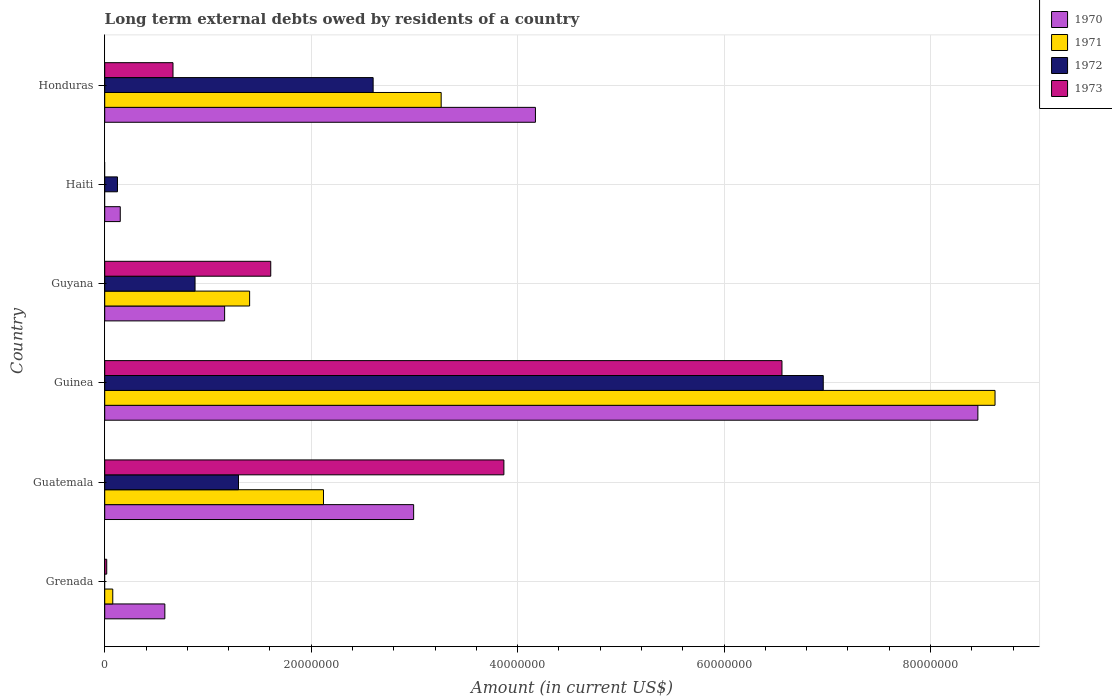How many groups of bars are there?
Offer a terse response. 6. Are the number of bars on each tick of the Y-axis equal?
Keep it short and to the point. No. How many bars are there on the 5th tick from the bottom?
Offer a very short reply. 2. What is the label of the 3rd group of bars from the top?
Ensure brevity in your answer.  Guyana. What is the amount of long-term external debts owed by residents in 1972 in Guyana?
Your response must be concise. 8.75e+06. Across all countries, what is the maximum amount of long-term external debts owed by residents in 1971?
Keep it short and to the point. 8.63e+07. Across all countries, what is the minimum amount of long-term external debts owed by residents in 1970?
Keep it short and to the point. 1.51e+06. In which country was the amount of long-term external debts owed by residents in 1973 maximum?
Your response must be concise. Guinea. What is the total amount of long-term external debts owed by residents in 1970 in the graph?
Your response must be concise. 1.75e+08. What is the difference between the amount of long-term external debts owed by residents in 1973 in Guinea and that in Guyana?
Make the answer very short. 4.95e+07. What is the difference between the amount of long-term external debts owed by residents in 1973 in Guinea and the amount of long-term external debts owed by residents in 1972 in Guatemala?
Your response must be concise. 5.27e+07. What is the average amount of long-term external debts owed by residents in 1972 per country?
Provide a succinct answer. 1.98e+07. What is the difference between the amount of long-term external debts owed by residents in 1971 and amount of long-term external debts owed by residents in 1973 in Guyana?
Keep it short and to the point. -2.05e+06. What is the ratio of the amount of long-term external debts owed by residents in 1971 in Grenada to that in Guyana?
Your response must be concise. 0.06. Is the difference between the amount of long-term external debts owed by residents in 1971 in Guatemala and Guinea greater than the difference between the amount of long-term external debts owed by residents in 1973 in Guatemala and Guinea?
Ensure brevity in your answer.  No. What is the difference between the highest and the second highest amount of long-term external debts owed by residents in 1973?
Your answer should be very brief. 2.69e+07. What is the difference between the highest and the lowest amount of long-term external debts owed by residents in 1971?
Your response must be concise. 8.63e+07. In how many countries, is the amount of long-term external debts owed by residents in 1970 greater than the average amount of long-term external debts owed by residents in 1970 taken over all countries?
Your answer should be compact. 3. Is the sum of the amount of long-term external debts owed by residents in 1972 in Guatemala and Guyana greater than the maximum amount of long-term external debts owed by residents in 1971 across all countries?
Offer a terse response. No. Is it the case that in every country, the sum of the amount of long-term external debts owed by residents in 1972 and amount of long-term external debts owed by residents in 1971 is greater than the amount of long-term external debts owed by residents in 1973?
Give a very brief answer. No. Are all the bars in the graph horizontal?
Keep it short and to the point. Yes. Are the values on the major ticks of X-axis written in scientific E-notation?
Offer a very short reply. No. Does the graph contain any zero values?
Offer a terse response. Yes. Does the graph contain grids?
Your answer should be compact. Yes. Where does the legend appear in the graph?
Offer a terse response. Top right. How many legend labels are there?
Offer a terse response. 4. What is the title of the graph?
Your answer should be very brief. Long term external debts owed by residents of a country. What is the label or title of the X-axis?
Offer a very short reply. Amount (in current US$). What is the Amount (in current US$) in 1970 in Grenada?
Ensure brevity in your answer.  5.82e+06. What is the Amount (in current US$) of 1971 in Grenada?
Give a very brief answer. 7.80e+05. What is the Amount (in current US$) in 1972 in Grenada?
Your answer should be compact. 0. What is the Amount (in current US$) in 1973 in Grenada?
Provide a short and direct response. 1.95e+05. What is the Amount (in current US$) in 1970 in Guatemala?
Ensure brevity in your answer.  2.99e+07. What is the Amount (in current US$) of 1971 in Guatemala?
Keep it short and to the point. 2.12e+07. What is the Amount (in current US$) of 1972 in Guatemala?
Your response must be concise. 1.30e+07. What is the Amount (in current US$) of 1973 in Guatemala?
Offer a terse response. 3.87e+07. What is the Amount (in current US$) in 1970 in Guinea?
Keep it short and to the point. 8.46e+07. What is the Amount (in current US$) in 1971 in Guinea?
Your answer should be compact. 8.63e+07. What is the Amount (in current US$) in 1972 in Guinea?
Make the answer very short. 6.96e+07. What is the Amount (in current US$) of 1973 in Guinea?
Your answer should be compact. 6.56e+07. What is the Amount (in current US$) of 1970 in Guyana?
Provide a short and direct response. 1.16e+07. What is the Amount (in current US$) of 1971 in Guyana?
Give a very brief answer. 1.40e+07. What is the Amount (in current US$) of 1972 in Guyana?
Offer a terse response. 8.75e+06. What is the Amount (in current US$) in 1973 in Guyana?
Offer a terse response. 1.61e+07. What is the Amount (in current US$) in 1970 in Haiti?
Give a very brief answer. 1.51e+06. What is the Amount (in current US$) of 1971 in Haiti?
Provide a short and direct response. 0. What is the Amount (in current US$) of 1972 in Haiti?
Offer a very short reply. 1.24e+06. What is the Amount (in current US$) in 1973 in Haiti?
Your answer should be compact. 0. What is the Amount (in current US$) of 1970 in Honduras?
Your response must be concise. 4.17e+07. What is the Amount (in current US$) in 1971 in Honduras?
Your answer should be very brief. 3.26e+07. What is the Amount (in current US$) in 1972 in Honduras?
Offer a very short reply. 2.60e+07. What is the Amount (in current US$) in 1973 in Honduras?
Provide a succinct answer. 6.62e+06. Across all countries, what is the maximum Amount (in current US$) of 1970?
Ensure brevity in your answer.  8.46e+07. Across all countries, what is the maximum Amount (in current US$) of 1971?
Ensure brevity in your answer.  8.63e+07. Across all countries, what is the maximum Amount (in current US$) of 1972?
Ensure brevity in your answer.  6.96e+07. Across all countries, what is the maximum Amount (in current US$) of 1973?
Keep it short and to the point. 6.56e+07. Across all countries, what is the minimum Amount (in current US$) in 1970?
Offer a very short reply. 1.51e+06. Across all countries, what is the minimum Amount (in current US$) of 1971?
Your answer should be compact. 0. What is the total Amount (in current US$) of 1970 in the graph?
Provide a short and direct response. 1.75e+08. What is the total Amount (in current US$) of 1971 in the graph?
Offer a terse response. 1.55e+08. What is the total Amount (in current US$) in 1972 in the graph?
Provide a short and direct response. 1.19e+08. What is the total Amount (in current US$) in 1973 in the graph?
Offer a terse response. 1.27e+08. What is the difference between the Amount (in current US$) in 1970 in Grenada and that in Guatemala?
Provide a succinct answer. -2.41e+07. What is the difference between the Amount (in current US$) in 1971 in Grenada and that in Guatemala?
Make the answer very short. -2.04e+07. What is the difference between the Amount (in current US$) of 1973 in Grenada and that in Guatemala?
Provide a short and direct response. -3.85e+07. What is the difference between the Amount (in current US$) in 1970 in Grenada and that in Guinea?
Keep it short and to the point. -7.88e+07. What is the difference between the Amount (in current US$) of 1971 in Grenada and that in Guinea?
Make the answer very short. -8.55e+07. What is the difference between the Amount (in current US$) of 1973 in Grenada and that in Guinea?
Make the answer very short. -6.54e+07. What is the difference between the Amount (in current US$) in 1970 in Grenada and that in Guyana?
Keep it short and to the point. -5.79e+06. What is the difference between the Amount (in current US$) in 1971 in Grenada and that in Guyana?
Offer a very short reply. -1.33e+07. What is the difference between the Amount (in current US$) in 1973 in Grenada and that in Guyana?
Provide a short and direct response. -1.59e+07. What is the difference between the Amount (in current US$) of 1970 in Grenada and that in Haiti?
Keep it short and to the point. 4.32e+06. What is the difference between the Amount (in current US$) of 1970 in Grenada and that in Honduras?
Your answer should be very brief. -3.59e+07. What is the difference between the Amount (in current US$) of 1971 in Grenada and that in Honduras?
Ensure brevity in your answer.  -3.18e+07. What is the difference between the Amount (in current US$) in 1973 in Grenada and that in Honduras?
Your answer should be compact. -6.42e+06. What is the difference between the Amount (in current US$) in 1970 in Guatemala and that in Guinea?
Make the answer very short. -5.47e+07. What is the difference between the Amount (in current US$) in 1971 in Guatemala and that in Guinea?
Make the answer very short. -6.51e+07. What is the difference between the Amount (in current US$) in 1972 in Guatemala and that in Guinea?
Provide a succinct answer. -5.67e+07. What is the difference between the Amount (in current US$) in 1973 in Guatemala and that in Guinea?
Your response must be concise. -2.69e+07. What is the difference between the Amount (in current US$) of 1970 in Guatemala and that in Guyana?
Offer a very short reply. 1.83e+07. What is the difference between the Amount (in current US$) in 1971 in Guatemala and that in Guyana?
Your response must be concise. 7.16e+06. What is the difference between the Amount (in current US$) in 1972 in Guatemala and that in Guyana?
Your answer should be very brief. 4.21e+06. What is the difference between the Amount (in current US$) of 1973 in Guatemala and that in Guyana?
Make the answer very short. 2.26e+07. What is the difference between the Amount (in current US$) of 1970 in Guatemala and that in Haiti?
Offer a terse response. 2.84e+07. What is the difference between the Amount (in current US$) in 1972 in Guatemala and that in Haiti?
Offer a very short reply. 1.17e+07. What is the difference between the Amount (in current US$) in 1970 in Guatemala and that in Honduras?
Offer a terse response. -1.18e+07. What is the difference between the Amount (in current US$) of 1971 in Guatemala and that in Honduras?
Your answer should be very brief. -1.14e+07. What is the difference between the Amount (in current US$) in 1972 in Guatemala and that in Honduras?
Your answer should be very brief. -1.30e+07. What is the difference between the Amount (in current US$) of 1973 in Guatemala and that in Honduras?
Offer a very short reply. 3.21e+07. What is the difference between the Amount (in current US$) in 1970 in Guinea and that in Guyana?
Make the answer very short. 7.30e+07. What is the difference between the Amount (in current US$) of 1971 in Guinea and that in Guyana?
Your response must be concise. 7.22e+07. What is the difference between the Amount (in current US$) of 1972 in Guinea and that in Guyana?
Keep it short and to the point. 6.09e+07. What is the difference between the Amount (in current US$) in 1973 in Guinea and that in Guyana?
Keep it short and to the point. 4.95e+07. What is the difference between the Amount (in current US$) in 1970 in Guinea and that in Haiti?
Your answer should be compact. 8.31e+07. What is the difference between the Amount (in current US$) in 1972 in Guinea and that in Haiti?
Your answer should be very brief. 6.84e+07. What is the difference between the Amount (in current US$) of 1970 in Guinea and that in Honduras?
Your answer should be very brief. 4.29e+07. What is the difference between the Amount (in current US$) in 1971 in Guinea and that in Honduras?
Provide a short and direct response. 5.37e+07. What is the difference between the Amount (in current US$) of 1972 in Guinea and that in Honduras?
Provide a succinct answer. 4.36e+07. What is the difference between the Amount (in current US$) in 1973 in Guinea and that in Honduras?
Provide a succinct answer. 5.90e+07. What is the difference between the Amount (in current US$) in 1970 in Guyana and that in Haiti?
Give a very brief answer. 1.01e+07. What is the difference between the Amount (in current US$) of 1972 in Guyana and that in Haiti?
Make the answer very short. 7.52e+06. What is the difference between the Amount (in current US$) in 1970 in Guyana and that in Honduras?
Ensure brevity in your answer.  -3.01e+07. What is the difference between the Amount (in current US$) in 1971 in Guyana and that in Honduras?
Make the answer very short. -1.86e+07. What is the difference between the Amount (in current US$) of 1972 in Guyana and that in Honduras?
Your answer should be compact. -1.73e+07. What is the difference between the Amount (in current US$) of 1973 in Guyana and that in Honduras?
Give a very brief answer. 9.47e+06. What is the difference between the Amount (in current US$) of 1970 in Haiti and that in Honduras?
Ensure brevity in your answer.  -4.02e+07. What is the difference between the Amount (in current US$) of 1972 in Haiti and that in Honduras?
Provide a succinct answer. -2.48e+07. What is the difference between the Amount (in current US$) in 1970 in Grenada and the Amount (in current US$) in 1971 in Guatemala?
Give a very brief answer. -1.54e+07. What is the difference between the Amount (in current US$) in 1970 in Grenada and the Amount (in current US$) in 1972 in Guatemala?
Your response must be concise. -7.14e+06. What is the difference between the Amount (in current US$) in 1970 in Grenada and the Amount (in current US$) in 1973 in Guatemala?
Ensure brevity in your answer.  -3.28e+07. What is the difference between the Amount (in current US$) in 1971 in Grenada and the Amount (in current US$) in 1972 in Guatemala?
Your answer should be very brief. -1.22e+07. What is the difference between the Amount (in current US$) of 1971 in Grenada and the Amount (in current US$) of 1973 in Guatemala?
Your answer should be very brief. -3.79e+07. What is the difference between the Amount (in current US$) in 1970 in Grenada and the Amount (in current US$) in 1971 in Guinea?
Make the answer very short. -8.04e+07. What is the difference between the Amount (in current US$) of 1970 in Grenada and the Amount (in current US$) of 1972 in Guinea?
Offer a very short reply. -6.38e+07. What is the difference between the Amount (in current US$) of 1970 in Grenada and the Amount (in current US$) of 1973 in Guinea?
Provide a succinct answer. -5.98e+07. What is the difference between the Amount (in current US$) of 1971 in Grenada and the Amount (in current US$) of 1972 in Guinea?
Your answer should be compact. -6.88e+07. What is the difference between the Amount (in current US$) in 1971 in Grenada and the Amount (in current US$) in 1973 in Guinea?
Provide a short and direct response. -6.48e+07. What is the difference between the Amount (in current US$) of 1970 in Grenada and the Amount (in current US$) of 1971 in Guyana?
Keep it short and to the point. -8.22e+06. What is the difference between the Amount (in current US$) in 1970 in Grenada and the Amount (in current US$) in 1972 in Guyana?
Provide a succinct answer. -2.93e+06. What is the difference between the Amount (in current US$) of 1970 in Grenada and the Amount (in current US$) of 1973 in Guyana?
Provide a succinct answer. -1.03e+07. What is the difference between the Amount (in current US$) of 1971 in Grenada and the Amount (in current US$) of 1972 in Guyana?
Provide a succinct answer. -7.97e+06. What is the difference between the Amount (in current US$) in 1971 in Grenada and the Amount (in current US$) in 1973 in Guyana?
Provide a succinct answer. -1.53e+07. What is the difference between the Amount (in current US$) of 1970 in Grenada and the Amount (in current US$) of 1972 in Haiti?
Keep it short and to the point. 4.59e+06. What is the difference between the Amount (in current US$) of 1971 in Grenada and the Amount (in current US$) of 1972 in Haiti?
Your answer should be very brief. -4.55e+05. What is the difference between the Amount (in current US$) of 1970 in Grenada and the Amount (in current US$) of 1971 in Honduras?
Offer a terse response. -2.68e+07. What is the difference between the Amount (in current US$) of 1970 in Grenada and the Amount (in current US$) of 1972 in Honduras?
Provide a short and direct response. -2.02e+07. What is the difference between the Amount (in current US$) in 1970 in Grenada and the Amount (in current US$) in 1973 in Honduras?
Make the answer very short. -7.90e+05. What is the difference between the Amount (in current US$) in 1971 in Grenada and the Amount (in current US$) in 1972 in Honduras?
Your answer should be compact. -2.52e+07. What is the difference between the Amount (in current US$) in 1971 in Grenada and the Amount (in current US$) in 1973 in Honduras?
Give a very brief answer. -5.84e+06. What is the difference between the Amount (in current US$) in 1970 in Guatemala and the Amount (in current US$) in 1971 in Guinea?
Ensure brevity in your answer.  -5.63e+07. What is the difference between the Amount (in current US$) of 1970 in Guatemala and the Amount (in current US$) of 1972 in Guinea?
Provide a succinct answer. -3.97e+07. What is the difference between the Amount (in current US$) of 1970 in Guatemala and the Amount (in current US$) of 1973 in Guinea?
Make the answer very short. -3.57e+07. What is the difference between the Amount (in current US$) of 1971 in Guatemala and the Amount (in current US$) of 1972 in Guinea?
Ensure brevity in your answer.  -4.84e+07. What is the difference between the Amount (in current US$) in 1971 in Guatemala and the Amount (in current US$) in 1973 in Guinea?
Keep it short and to the point. -4.44e+07. What is the difference between the Amount (in current US$) of 1972 in Guatemala and the Amount (in current US$) of 1973 in Guinea?
Offer a terse response. -5.27e+07. What is the difference between the Amount (in current US$) in 1970 in Guatemala and the Amount (in current US$) in 1971 in Guyana?
Provide a short and direct response. 1.59e+07. What is the difference between the Amount (in current US$) of 1970 in Guatemala and the Amount (in current US$) of 1972 in Guyana?
Ensure brevity in your answer.  2.12e+07. What is the difference between the Amount (in current US$) of 1970 in Guatemala and the Amount (in current US$) of 1973 in Guyana?
Your answer should be very brief. 1.38e+07. What is the difference between the Amount (in current US$) in 1971 in Guatemala and the Amount (in current US$) in 1972 in Guyana?
Your response must be concise. 1.24e+07. What is the difference between the Amount (in current US$) of 1971 in Guatemala and the Amount (in current US$) of 1973 in Guyana?
Offer a very short reply. 5.11e+06. What is the difference between the Amount (in current US$) of 1972 in Guatemala and the Amount (in current US$) of 1973 in Guyana?
Give a very brief answer. -3.12e+06. What is the difference between the Amount (in current US$) of 1970 in Guatemala and the Amount (in current US$) of 1972 in Haiti?
Ensure brevity in your answer.  2.87e+07. What is the difference between the Amount (in current US$) of 1971 in Guatemala and the Amount (in current US$) of 1972 in Haiti?
Offer a terse response. 2.00e+07. What is the difference between the Amount (in current US$) in 1970 in Guatemala and the Amount (in current US$) in 1971 in Honduras?
Your answer should be very brief. -2.67e+06. What is the difference between the Amount (in current US$) in 1970 in Guatemala and the Amount (in current US$) in 1972 in Honduras?
Provide a short and direct response. 3.92e+06. What is the difference between the Amount (in current US$) in 1970 in Guatemala and the Amount (in current US$) in 1973 in Honduras?
Provide a succinct answer. 2.33e+07. What is the difference between the Amount (in current US$) in 1971 in Guatemala and the Amount (in current US$) in 1972 in Honduras?
Offer a terse response. -4.81e+06. What is the difference between the Amount (in current US$) of 1971 in Guatemala and the Amount (in current US$) of 1973 in Honduras?
Give a very brief answer. 1.46e+07. What is the difference between the Amount (in current US$) of 1972 in Guatemala and the Amount (in current US$) of 1973 in Honduras?
Provide a short and direct response. 6.35e+06. What is the difference between the Amount (in current US$) of 1970 in Guinea and the Amount (in current US$) of 1971 in Guyana?
Provide a succinct answer. 7.06e+07. What is the difference between the Amount (in current US$) in 1970 in Guinea and the Amount (in current US$) in 1972 in Guyana?
Provide a succinct answer. 7.58e+07. What is the difference between the Amount (in current US$) of 1970 in Guinea and the Amount (in current US$) of 1973 in Guyana?
Ensure brevity in your answer.  6.85e+07. What is the difference between the Amount (in current US$) in 1971 in Guinea and the Amount (in current US$) in 1972 in Guyana?
Your answer should be very brief. 7.75e+07. What is the difference between the Amount (in current US$) in 1971 in Guinea and the Amount (in current US$) in 1973 in Guyana?
Provide a short and direct response. 7.02e+07. What is the difference between the Amount (in current US$) of 1972 in Guinea and the Amount (in current US$) of 1973 in Guyana?
Your answer should be compact. 5.35e+07. What is the difference between the Amount (in current US$) in 1970 in Guinea and the Amount (in current US$) in 1972 in Haiti?
Offer a very short reply. 8.34e+07. What is the difference between the Amount (in current US$) in 1971 in Guinea and the Amount (in current US$) in 1972 in Haiti?
Give a very brief answer. 8.50e+07. What is the difference between the Amount (in current US$) in 1970 in Guinea and the Amount (in current US$) in 1971 in Honduras?
Ensure brevity in your answer.  5.20e+07. What is the difference between the Amount (in current US$) in 1970 in Guinea and the Amount (in current US$) in 1972 in Honduras?
Provide a succinct answer. 5.86e+07. What is the difference between the Amount (in current US$) in 1970 in Guinea and the Amount (in current US$) in 1973 in Honduras?
Provide a succinct answer. 7.80e+07. What is the difference between the Amount (in current US$) of 1971 in Guinea and the Amount (in current US$) of 1972 in Honduras?
Make the answer very short. 6.03e+07. What is the difference between the Amount (in current US$) in 1971 in Guinea and the Amount (in current US$) in 1973 in Honduras?
Give a very brief answer. 7.96e+07. What is the difference between the Amount (in current US$) of 1972 in Guinea and the Amount (in current US$) of 1973 in Honduras?
Keep it short and to the point. 6.30e+07. What is the difference between the Amount (in current US$) in 1970 in Guyana and the Amount (in current US$) in 1972 in Haiti?
Ensure brevity in your answer.  1.04e+07. What is the difference between the Amount (in current US$) of 1971 in Guyana and the Amount (in current US$) of 1972 in Haiti?
Provide a short and direct response. 1.28e+07. What is the difference between the Amount (in current US$) in 1970 in Guyana and the Amount (in current US$) in 1971 in Honduras?
Your answer should be very brief. -2.10e+07. What is the difference between the Amount (in current US$) in 1970 in Guyana and the Amount (in current US$) in 1972 in Honduras?
Make the answer very short. -1.44e+07. What is the difference between the Amount (in current US$) in 1970 in Guyana and the Amount (in current US$) in 1973 in Honduras?
Offer a very short reply. 5.00e+06. What is the difference between the Amount (in current US$) of 1971 in Guyana and the Amount (in current US$) of 1972 in Honduras?
Keep it short and to the point. -1.20e+07. What is the difference between the Amount (in current US$) in 1971 in Guyana and the Amount (in current US$) in 1973 in Honduras?
Your response must be concise. 7.42e+06. What is the difference between the Amount (in current US$) of 1972 in Guyana and the Amount (in current US$) of 1973 in Honduras?
Your response must be concise. 2.14e+06. What is the difference between the Amount (in current US$) in 1970 in Haiti and the Amount (in current US$) in 1971 in Honduras?
Offer a very short reply. -3.11e+07. What is the difference between the Amount (in current US$) in 1970 in Haiti and the Amount (in current US$) in 1972 in Honduras?
Your answer should be very brief. -2.45e+07. What is the difference between the Amount (in current US$) in 1970 in Haiti and the Amount (in current US$) in 1973 in Honduras?
Make the answer very short. -5.11e+06. What is the difference between the Amount (in current US$) in 1972 in Haiti and the Amount (in current US$) in 1973 in Honduras?
Provide a succinct answer. -5.38e+06. What is the average Amount (in current US$) of 1970 per country?
Make the answer very short. 2.92e+07. What is the average Amount (in current US$) of 1971 per country?
Keep it short and to the point. 2.58e+07. What is the average Amount (in current US$) of 1972 per country?
Your answer should be compact. 1.98e+07. What is the average Amount (in current US$) of 1973 per country?
Provide a succinct answer. 2.12e+07. What is the difference between the Amount (in current US$) of 1970 and Amount (in current US$) of 1971 in Grenada?
Provide a short and direct response. 5.04e+06. What is the difference between the Amount (in current US$) of 1970 and Amount (in current US$) of 1973 in Grenada?
Offer a very short reply. 5.63e+06. What is the difference between the Amount (in current US$) in 1971 and Amount (in current US$) in 1973 in Grenada?
Make the answer very short. 5.85e+05. What is the difference between the Amount (in current US$) of 1970 and Amount (in current US$) of 1971 in Guatemala?
Provide a succinct answer. 8.73e+06. What is the difference between the Amount (in current US$) in 1970 and Amount (in current US$) in 1972 in Guatemala?
Offer a terse response. 1.70e+07. What is the difference between the Amount (in current US$) in 1970 and Amount (in current US$) in 1973 in Guatemala?
Give a very brief answer. -8.74e+06. What is the difference between the Amount (in current US$) in 1971 and Amount (in current US$) in 1972 in Guatemala?
Make the answer very short. 8.23e+06. What is the difference between the Amount (in current US$) of 1971 and Amount (in current US$) of 1973 in Guatemala?
Your answer should be very brief. -1.75e+07. What is the difference between the Amount (in current US$) of 1972 and Amount (in current US$) of 1973 in Guatemala?
Provide a short and direct response. -2.57e+07. What is the difference between the Amount (in current US$) in 1970 and Amount (in current US$) in 1971 in Guinea?
Ensure brevity in your answer.  -1.66e+06. What is the difference between the Amount (in current US$) of 1970 and Amount (in current US$) of 1972 in Guinea?
Offer a terse response. 1.50e+07. What is the difference between the Amount (in current US$) of 1970 and Amount (in current US$) of 1973 in Guinea?
Offer a terse response. 1.90e+07. What is the difference between the Amount (in current US$) in 1971 and Amount (in current US$) in 1972 in Guinea?
Offer a terse response. 1.66e+07. What is the difference between the Amount (in current US$) in 1971 and Amount (in current US$) in 1973 in Guinea?
Offer a very short reply. 2.06e+07. What is the difference between the Amount (in current US$) in 1970 and Amount (in current US$) in 1971 in Guyana?
Your answer should be very brief. -2.42e+06. What is the difference between the Amount (in current US$) of 1970 and Amount (in current US$) of 1972 in Guyana?
Provide a succinct answer. 2.87e+06. What is the difference between the Amount (in current US$) of 1970 and Amount (in current US$) of 1973 in Guyana?
Your answer should be compact. -4.47e+06. What is the difference between the Amount (in current US$) in 1971 and Amount (in current US$) in 1972 in Guyana?
Make the answer very short. 5.29e+06. What is the difference between the Amount (in current US$) of 1971 and Amount (in current US$) of 1973 in Guyana?
Give a very brief answer. -2.05e+06. What is the difference between the Amount (in current US$) in 1972 and Amount (in current US$) in 1973 in Guyana?
Provide a succinct answer. -7.34e+06. What is the difference between the Amount (in current US$) of 1970 and Amount (in current US$) of 1972 in Haiti?
Ensure brevity in your answer.  2.72e+05. What is the difference between the Amount (in current US$) in 1970 and Amount (in current US$) in 1971 in Honduras?
Offer a very short reply. 9.13e+06. What is the difference between the Amount (in current US$) in 1970 and Amount (in current US$) in 1972 in Honduras?
Give a very brief answer. 1.57e+07. What is the difference between the Amount (in current US$) of 1970 and Amount (in current US$) of 1973 in Honduras?
Make the answer very short. 3.51e+07. What is the difference between the Amount (in current US$) of 1971 and Amount (in current US$) of 1972 in Honduras?
Your response must be concise. 6.59e+06. What is the difference between the Amount (in current US$) in 1971 and Amount (in current US$) in 1973 in Honduras?
Keep it short and to the point. 2.60e+07. What is the difference between the Amount (in current US$) of 1972 and Amount (in current US$) of 1973 in Honduras?
Make the answer very short. 1.94e+07. What is the ratio of the Amount (in current US$) in 1970 in Grenada to that in Guatemala?
Ensure brevity in your answer.  0.19. What is the ratio of the Amount (in current US$) of 1971 in Grenada to that in Guatemala?
Give a very brief answer. 0.04. What is the ratio of the Amount (in current US$) in 1973 in Grenada to that in Guatemala?
Provide a short and direct response. 0.01. What is the ratio of the Amount (in current US$) in 1970 in Grenada to that in Guinea?
Offer a terse response. 0.07. What is the ratio of the Amount (in current US$) in 1971 in Grenada to that in Guinea?
Your answer should be compact. 0.01. What is the ratio of the Amount (in current US$) of 1973 in Grenada to that in Guinea?
Your response must be concise. 0. What is the ratio of the Amount (in current US$) in 1970 in Grenada to that in Guyana?
Offer a very short reply. 0.5. What is the ratio of the Amount (in current US$) of 1971 in Grenada to that in Guyana?
Your answer should be very brief. 0.06. What is the ratio of the Amount (in current US$) of 1973 in Grenada to that in Guyana?
Offer a very short reply. 0.01. What is the ratio of the Amount (in current US$) of 1970 in Grenada to that in Haiti?
Give a very brief answer. 3.87. What is the ratio of the Amount (in current US$) of 1970 in Grenada to that in Honduras?
Your response must be concise. 0.14. What is the ratio of the Amount (in current US$) of 1971 in Grenada to that in Honduras?
Make the answer very short. 0.02. What is the ratio of the Amount (in current US$) in 1973 in Grenada to that in Honduras?
Give a very brief answer. 0.03. What is the ratio of the Amount (in current US$) of 1970 in Guatemala to that in Guinea?
Offer a terse response. 0.35. What is the ratio of the Amount (in current US$) of 1971 in Guatemala to that in Guinea?
Your answer should be very brief. 0.25. What is the ratio of the Amount (in current US$) in 1972 in Guatemala to that in Guinea?
Your answer should be very brief. 0.19. What is the ratio of the Amount (in current US$) of 1973 in Guatemala to that in Guinea?
Ensure brevity in your answer.  0.59. What is the ratio of the Amount (in current US$) in 1970 in Guatemala to that in Guyana?
Your response must be concise. 2.58. What is the ratio of the Amount (in current US$) in 1971 in Guatemala to that in Guyana?
Provide a short and direct response. 1.51. What is the ratio of the Amount (in current US$) in 1972 in Guatemala to that in Guyana?
Provide a short and direct response. 1.48. What is the ratio of the Amount (in current US$) of 1973 in Guatemala to that in Guyana?
Keep it short and to the point. 2.4. What is the ratio of the Amount (in current US$) of 1970 in Guatemala to that in Haiti?
Your response must be concise. 19.86. What is the ratio of the Amount (in current US$) in 1972 in Guatemala to that in Haiti?
Provide a short and direct response. 10.5. What is the ratio of the Amount (in current US$) in 1970 in Guatemala to that in Honduras?
Ensure brevity in your answer.  0.72. What is the ratio of the Amount (in current US$) of 1971 in Guatemala to that in Honduras?
Offer a very short reply. 0.65. What is the ratio of the Amount (in current US$) in 1972 in Guatemala to that in Honduras?
Ensure brevity in your answer.  0.5. What is the ratio of the Amount (in current US$) of 1973 in Guatemala to that in Honduras?
Your answer should be very brief. 5.85. What is the ratio of the Amount (in current US$) of 1970 in Guinea to that in Guyana?
Provide a short and direct response. 7.28. What is the ratio of the Amount (in current US$) in 1971 in Guinea to that in Guyana?
Provide a short and direct response. 6.14. What is the ratio of the Amount (in current US$) in 1972 in Guinea to that in Guyana?
Provide a succinct answer. 7.96. What is the ratio of the Amount (in current US$) of 1973 in Guinea to that in Guyana?
Make the answer very short. 4.08. What is the ratio of the Amount (in current US$) in 1970 in Guinea to that in Haiti?
Make the answer very short. 56.14. What is the ratio of the Amount (in current US$) in 1972 in Guinea to that in Haiti?
Your answer should be very brief. 56.37. What is the ratio of the Amount (in current US$) of 1970 in Guinea to that in Honduras?
Ensure brevity in your answer.  2.03. What is the ratio of the Amount (in current US$) in 1971 in Guinea to that in Honduras?
Ensure brevity in your answer.  2.65. What is the ratio of the Amount (in current US$) in 1972 in Guinea to that in Honduras?
Provide a short and direct response. 2.68. What is the ratio of the Amount (in current US$) in 1973 in Guinea to that in Honduras?
Provide a succinct answer. 9.92. What is the ratio of the Amount (in current US$) in 1970 in Guyana to that in Haiti?
Offer a terse response. 7.71. What is the ratio of the Amount (in current US$) of 1972 in Guyana to that in Haiti?
Provide a succinct answer. 7.09. What is the ratio of the Amount (in current US$) in 1970 in Guyana to that in Honduras?
Your answer should be very brief. 0.28. What is the ratio of the Amount (in current US$) of 1971 in Guyana to that in Honduras?
Offer a very short reply. 0.43. What is the ratio of the Amount (in current US$) in 1972 in Guyana to that in Honduras?
Your answer should be compact. 0.34. What is the ratio of the Amount (in current US$) in 1973 in Guyana to that in Honduras?
Your response must be concise. 2.43. What is the ratio of the Amount (in current US$) of 1970 in Haiti to that in Honduras?
Your answer should be compact. 0.04. What is the ratio of the Amount (in current US$) of 1972 in Haiti to that in Honduras?
Your response must be concise. 0.05. What is the difference between the highest and the second highest Amount (in current US$) in 1970?
Provide a succinct answer. 4.29e+07. What is the difference between the highest and the second highest Amount (in current US$) of 1971?
Give a very brief answer. 5.37e+07. What is the difference between the highest and the second highest Amount (in current US$) of 1972?
Offer a terse response. 4.36e+07. What is the difference between the highest and the second highest Amount (in current US$) in 1973?
Provide a short and direct response. 2.69e+07. What is the difference between the highest and the lowest Amount (in current US$) in 1970?
Your response must be concise. 8.31e+07. What is the difference between the highest and the lowest Amount (in current US$) of 1971?
Make the answer very short. 8.63e+07. What is the difference between the highest and the lowest Amount (in current US$) in 1972?
Provide a succinct answer. 6.96e+07. What is the difference between the highest and the lowest Amount (in current US$) of 1973?
Your response must be concise. 6.56e+07. 